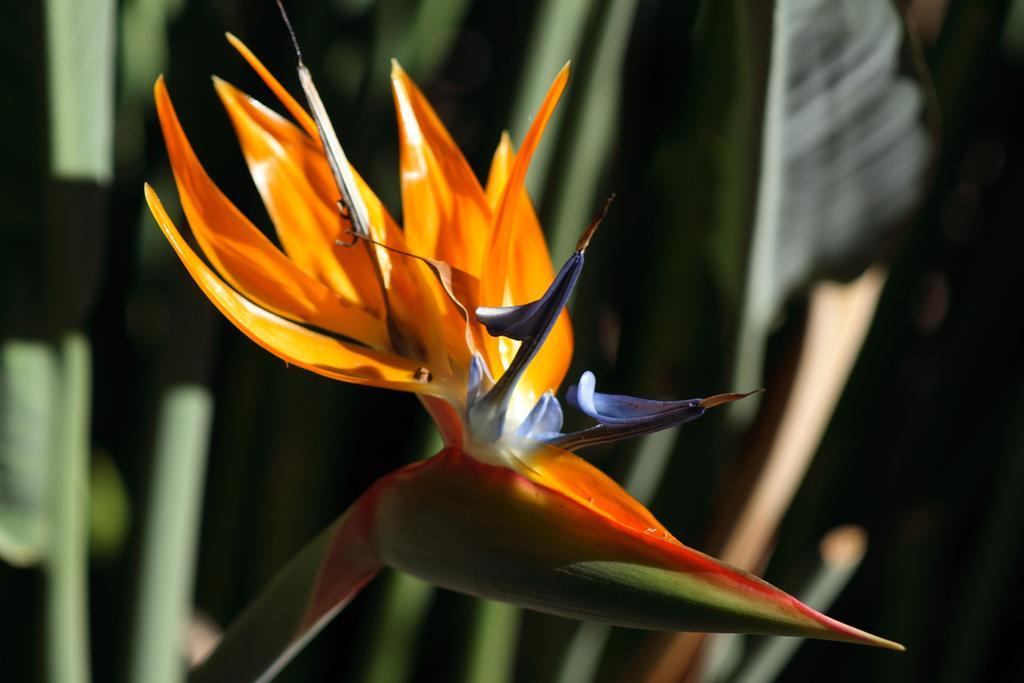Describe this image in one or two sentences. In the image we can see a flower, orange, purple and white in color. This is a stem of the flower and the background is blurred. 